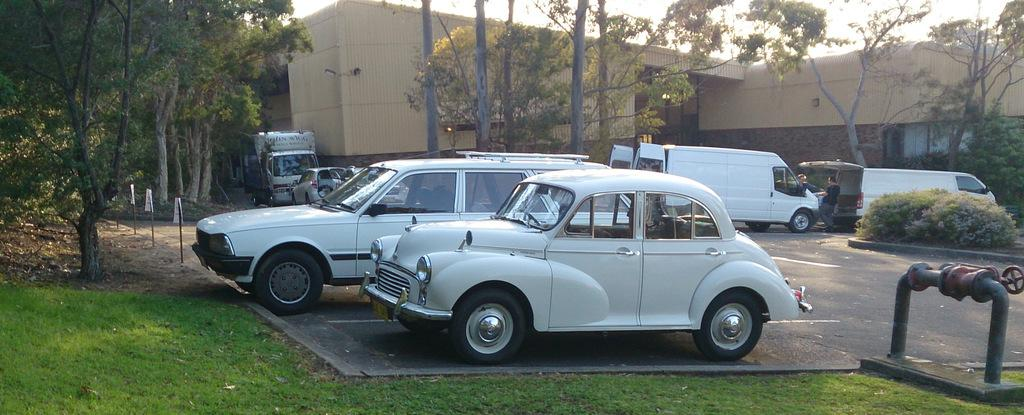What can be seen on the road in the image? There are vehicles on the road in the image. What type of vegetation is present in the image? There are trees and grass in the image. Can you describe the object with a wheel in the image? There is a metal pipe with a wheel in the image. What type of structures are visible in the image? There are poles and a building in the image. What type of window treatment is present in the image? There are curtains in the image. What type of lighting is present in the image? There is a light in the image. What can be seen in the background of the image? The sky is visible in the background of the image. Where is the toothpaste located in the image? There is no toothpaste present in the image. What type of door can be seen in the image? There is no door present in the image. 